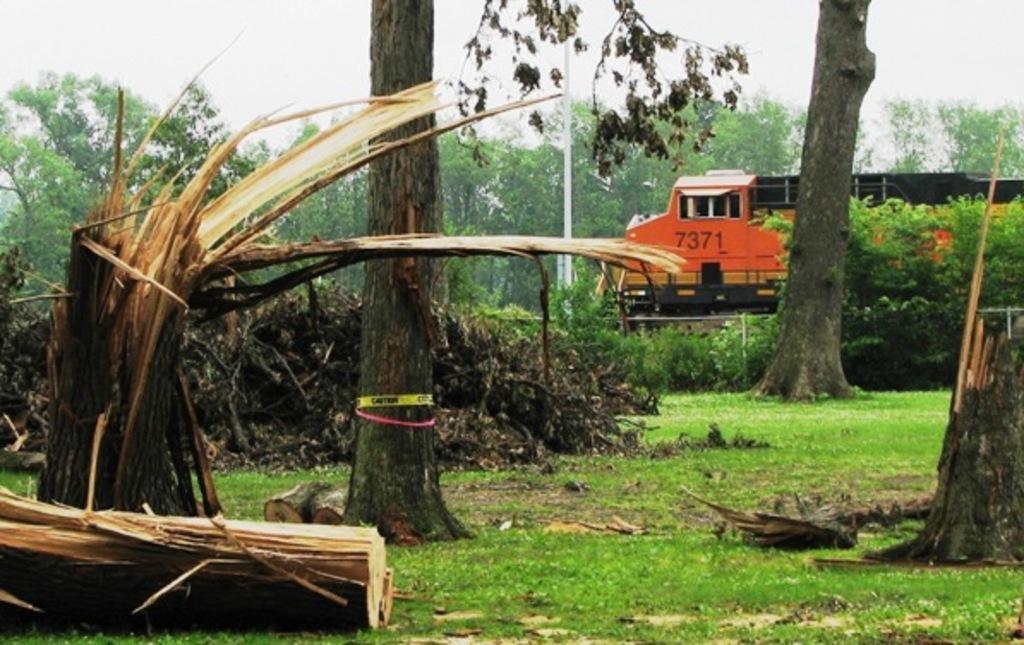How would you summarize this image in a sentence or two? On the ground there is grass. There are wooden logs. Also there are tree trunks. In the back there are trees. In the background there is sky. Also there is a vehicle. 